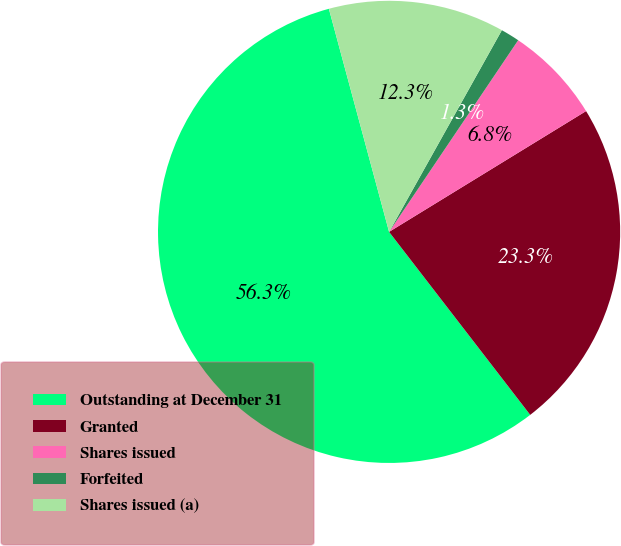<chart> <loc_0><loc_0><loc_500><loc_500><pie_chart><fcel>Outstanding at December 31<fcel>Granted<fcel>Shares issued<fcel>Forfeited<fcel>Shares issued (a)<nl><fcel>56.26%<fcel>23.3%<fcel>6.81%<fcel>1.32%<fcel>12.31%<nl></chart> 